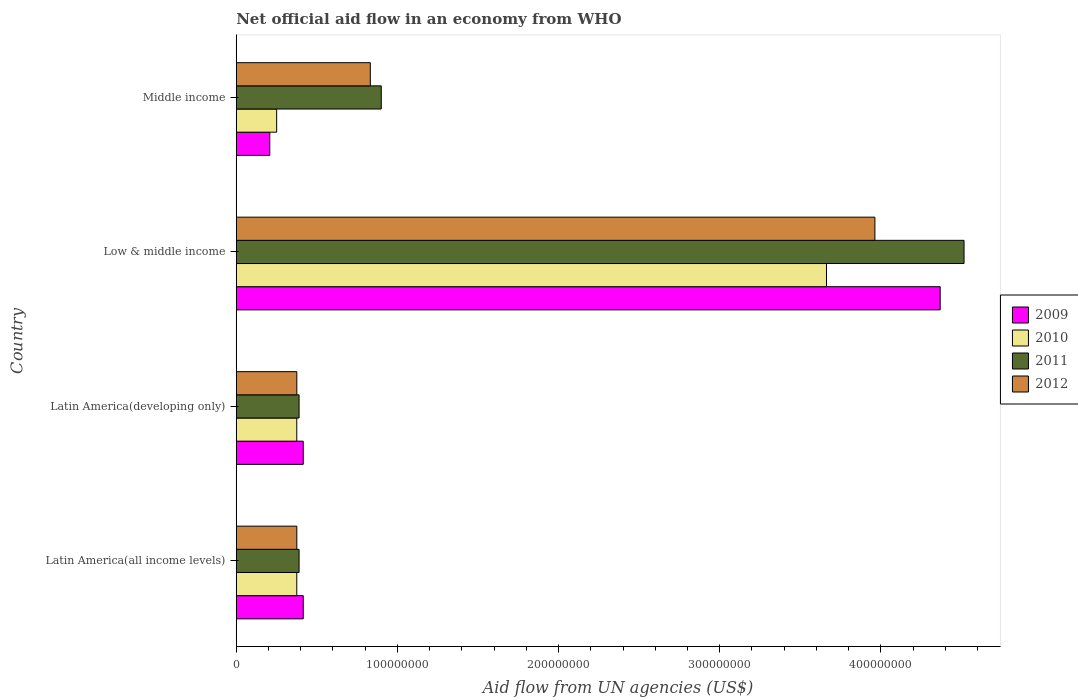Are the number of bars per tick equal to the number of legend labels?
Make the answer very short. Yes. Are the number of bars on each tick of the Y-axis equal?
Provide a short and direct response. Yes. How many bars are there on the 3rd tick from the bottom?
Offer a very short reply. 4. What is the label of the 1st group of bars from the top?
Ensure brevity in your answer.  Middle income. In how many cases, is the number of bars for a given country not equal to the number of legend labels?
Provide a succinct answer. 0. What is the net official aid flow in 2012 in Low & middle income?
Your answer should be very brief. 3.96e+08. Across all countries, what is the maximum net official aid flow in 2010?
Your answer should be very brief. 3.66e+08. Across all countries, what is the minimum net official aid flow in 2011?
Offer a very short reply. 3.90e+07. In which country was the net official aid flow in 2010 minimum?
Keep it short and to the point. Middle income. What is the total net official aid flow in 2011 in the graph?
Make the answer very short. 6.20e+08. What is the difference between the net official aid flow in 2009 in Latin America(all income levels) and that in Low & middle income?
Provide a short and direct response. -3.95e+08. What is the difference between the net official aid flow in 2012 in Latin America(all income levels) and the net official aid flow in 2011 in Latin America(developing only)?
Your answer should be compact. -1.40e+06. What is the average net official aid flow in 2009 per country?
Your answer should be compact. 1.35e+08. What is the difference between the net official aid flow in 2012 and net official aid flow in 2011 in Low & middle income?
Provide a short and direct response. -5.53e+07. What is the ratio of the net official aid flow in 2012 in Latin America(all income levels) to that in Low & middle income?
Offer a terse response. 0.09. Is the net official aid flow in 2012 in Latin America(developing only) less than that in Low & middle income?
Your response must be concise. Yes. Is the difference between the net official aid flow in 2012 in Low & middle income and Middle income greater than the difference between the net official aid flow in 2011 in Low & middle income and Middle income?
Provide a succinct answer. No. What is the difference between the highest and the second highest net official aid flow in 2011?
Make the answer very short. 3.62e+08. What is the difference between the highest and the lowest net official aid flow in 2011?
Your answer should be very brief. 4.13e+08. Is the sum of the net official aid flow in 2011 in Latin America(developing only) and Middle income greater than the maximum net official aid flow in 2009 across all countries?
Give a very brief answer. No. What does the 4th bar from the top in Low & middle income represents?
Give a very brief answer. 2009. What does the 4th bar from the bottom in Latin America(all income levels) represents?
Offer a terse response. 2012. Is it the case that in every country, the sum of the net official aid flow in 2011 and net official aid flow in 2010 is greater than the net official aid flow in 2012?
Offer a very short reply. Yes. How many bars are there?
Offer a terse response. 16. How many countries are there in the graph?
Your answer should be very brief. 4. Are the values on the major ticks of X-axis written in scientific E-notation?
Make the answer very short. No. Does the graph contain any zero values?
Keep it short and to the point. No. Does the graph contain grids?
Provide a succinct answer. No. How many legend labels are there?
Your answer should be very brief. 4. What is the title of the graph?
Make the answer very short. Net official aid flow in an economy from WHO. What is the label or title of the X-axis?
Provide a succinct answer. Aid flow from UN agencies (US$). What is the Aid flow from UN agencies (US$) of 2009 in Latin America(all income levels)?
Offer a terse response. 4.16e+07. What is the Aid flow from UN agencies (US$) of 2010 in Latin America(all income levels)?
Give a very brief answer. 3.76e+07. What is the Aid flow from UN agencies (US$) in 2011 in Latin America(all income levels)?
Your answer should be compact. 3.90e+07. What is the Aid flow from UN agencies (US$) of 2012 in Latin America(all income levels)?
Offer a terse response. 3.76e+07. What is the Aid flow from UN agencies (US$) of 2009 in Latin America(developing only)?
Keep it short and to the point. 4.16e+07. What is the Aid flow from UN agencies (US$) of 2010 in Latin America(developing only)?
Keep it short and to the point. 3.76e+07. What is the Aid flow from UN agencies (US$) in 2011 in Latin America(developing only)?
Your response must be concise. 3.90e+07. What is the Aid flow from UN agencies (US$) of 2012 in Latin America(developing only)?
Keep it short and to the point. 3.76e+07. What is the Aid flow from UN agencies (US$) in 2009 in Low & middle income?
Offer a very short reply. 4.37e+08. What is the Aid flow from UN agencies (US$) in 2010 in Low & middle income?
Give a very brief answer. 3.66e+08. What is the Aid flow from UN agencies (US$) in 2011 in Low & middle income?
Your answer should be compact. 4.52e+08. What is the Aid flow from UN agencies (US$) in 2012 in Low & middle income?
Your answer should be compact. 3.96e+08. What is the Aid flow from UN agencies (US$) of 2009 in Middle income?
Give a very brief answer. 2.08e+07. What is the Aid flow from UN agencies (US$) in 2010 in Middle income?
Provide a short and direct response. 2.51e+07. What is the Aid flow from UN agencies (US$) of 2011 in Middle income?
Make the answer very short. 9.00e+07. What is the Aid flow from UN agencies (US$) of 2012 in Middle income?
Ensure brevity in your answer.  8.32e+07. Across all countries, what is the maximum Aid flow from UN agencies (US$) of 2009?
Give a very brief answer. 4.37e+08. Across all countries, what is the maximum Aid flow from UN agencies (US$) of 2010?
Keep it short and to the point. 3.66e+08. Across all countries, what is the maximum Aid flow from UN agencies (US$) in 2011?
Make the answer very short. 4.52e+08. Across all countries, what is the maximum Aid flow from UN agencies (US$) of 2012?
Your response must be concise. 3.96e+08. Across all countries, what is the minimum Aid flow from UN agencies (US$) of 2009?
Make the answer very short. 2.08e+07. Across all countries, what is the minimum Aid flow from UN agencies (US$) of 2010?
Offer a very short reply. 2.51e+07. Across all countries, what is the minimum Aid flow from UN agencies (US$) of 2011?
Offer a terse response. 3.90e+07. Across all countries, what is the minimum Aid flow from UN agencies (US$) in 2012?
Your response must be concise. 3.76e+07. What is the total Aid flow from UN agencies (US$) of 2009 in the graph?
Provide a short and direct response. 5.41e+08. What is the total Aid flow from UN agencies (US$) of 2010 in the graph?
Your response must be concise. 4.66e+08. What is the total Aid flow from UN agencies (US$) in 2011 in the graph?
Your answer should be compact. 6.20e+08. What is the total Aid flow from UN agencies (US$) in 2012 in the graph?
Keep it short and to the point. 5.55e+08. What is the difference between the Aid flow from UN agencies (US$) in 2009 in Latin America(all income levels) and that in Latin America(developing only)?
Keep it short and to the point. 0. What is the difference between the Aid flow from UN agencies (US$) of 2010 in Latin America(all income levels) and that in Latin America(developing only)?
Ensure brevity in your answer.  0. What is the difference between the Aid flow from UN agencies (US$) of 2011 in Latin America(all income levels) and that in Latin America(developing only)?
Your response must be concise. 0. What is the difference between the Aid flow from UN agencies (US$) in 2009 in Latin America(all income levels) and that in Low & middle income?
Your answer should be very brief. -3.95e+08. What is the difference between the Aid flow from UN agencies (US$) of 2010 in Latin America(all income levels) and that in Low & middle income?
Give a very brief answer. -3.29e+08. What is the difference between the Aid flow from UN agencies (US$) in 2011 in Latin America(all income levels) and that in Low & middle income?
Keep it short and to the point. -4.13e+08. What is the difference between the Aid flow from UN agencies (US$) of 2012 in Latin America(all income levels) and that in Low & middle income?
Ensure brevity in your answer.  -3.59e+08. What is the difference between the Aid flow from UN agencies (US$) in 2009 in Latin America(all income levels) and that in Middle income?
Offer a terse response. 2.08e+07. What is the difference between the Aid flow from UN agencies (US$) in 2010 in Latin America(all income levels) and that in Middle income?
Provide a succinct answer. 1.25e+07. What is the difference between the Aid flow from UN agencies (US$) in 2011 in Latin America(all income levels) and that in Middle income?
Ensure brevity in your answer.  -5.10e+07. What is the difference between the Aid flow from UN agencies (US$) of 2012 in Latin America(all income levels) and that in Middle income?
Your answer should be compact. -4.56e+07. What is the difference between the Aid flow from UN agencies (US$) of 2009 in Latin America(developing only) and that in Low & middle income?
Your answer should be very brief. -3.95e+08. What is the difference between the Aid flow from UN agencies (US$) of 2010 in Latin America(developing only) and that in Low & middle income?
Offer a terse response. -3.29e+08. What is the difference between the Aid flow from UN agencies (US$) of 2011 in Latin America(developing only) and that in Low & middle income?
Provide a succinct answer. -4.13e+08. What is the difference between the Aid flow from UN agencies (US$) of 2012 in Latin America(developing only) and that in Low & middle income?
Offer a very short reply. -3.59e+08. What is the difference between the Aid flow from UN agencies (US$) of 2009 in Latin America(developing only) and that in Middle income?
Keep it short and to the point. 2.08e+07. What is the difference between the Aid flow from UN agencies (US$) in 2010 in Latin America(developing only) and that in Middle income?
Provide a succinct answer. 1.25e+07. What is the difference between the Aid flow from UN agencies (US$) of 2011 in Latin America(developing only) and that in Middle income?
Ensure brevity in your answer.  -5.10e+07. What is the difference between the Aid flow from UN agencies (US$) in 2012 in Latin America(developing only) and that in Middle income?
Provide a short and direct response. -4.56e+07. What is the difference between the Aid flow from UN agencies (US$) of 2009 in Low & middle income and that in Middle income?
Give a very brief answer. 4.16e+08. What is the difference between the Aid flow from UN agencies (US$) of 2010 in Low & middle income and that in Middle income?
Ensure brevity in your answer.  3.41e+08. What is the difference between the Aid flow from UN agencies (US$) in 2011 in Low & middle income and that in Middle income?
Offer a very short reply. 3.62e+08. What is the difference between the Aid flow from UN agencies (US$) of 2012 in Low & middle income and that in Middle income?
Your answer should be very brief. 3.13e+08. What is the difference between the Aid flow from UN agencies (US$) in 2009 in Latin America(all income levels) and the Aid flow from UN agencies (US$) in 2010 in Latin America(developing only)?
Your answer should be very brief. 4.01e+06. What is the difference between the Aid flow from UN agencies (US$) in 2009 in Latin America(all income levels) and the Aid flow from UN agencies (US$) in 2011 in Latin America(developing only)?
Offer a terse response. 2.59e+06. What is the difference between the Aid flow from UN agencies (US$) of 2009 in Latin America(all income levels) and the Aid flow from UN agencies (US$) of 2012 in Latin America(developing only)?
Give a very brief answer. 3.99e+06. What is the difference between the Aid flow from UN agencies (US$) in 2010 in Latin America(all income levels) and the Aid flow from UN agencies (US$) in 2011 in Latin America(developing only)?
Provide a succinct answer. -1.42e+06. What is the difference between the Aid flow from UN agencies (US$) in 2011 in Latin America(all income levels) and the Aid flow from UN agencies (US$) in 2012 in Latin America(developing only)?
Keep it short and to the point. 1.40e+06. What is the difference between the Aid flow from UN agencies (US$) of 2009 in Latin America(all income levels) and the Aid flow from UN agencies (US$) of 2010 in Low & middle income?
Provide a succinct answer. -3.25e+08. What is the difference between the Aid flow from UN agencies (US$) in 2009 in Latin America(all income levels) and the Aid flow from UN agencies (US$) in 2011 in Low & middle income?
Offer a terse response. -4.10e+08. What is the difference between the Aid flow from UN agencies (US$) in 2009 in Latin America(all income levels) and the Aid flow from UN agencies (US$) in 2012 in Low & middle income?
Offer a very short reply. -3.55e+08. What is the difference between the Aid flow from UN agencies (US$) in 2010 in Latin America(all income levels) and the Aid flow from UN agencies (US$) in 2011 in Low & middle income?
Your response must be concise. -4.14e+08. What is the difference between the Aid flow from UN agencies (US$) in 2010 in Latin America(all income levels) and the Aid flow from UN agencies (US$) in 2012 in Low & middle income?
Give a very brief answer. -3.59e+08. What is the difference between the Aid flow from UN agencies (US$) of 2011 in Latin America(all income levels) and the Aid flow from UN agencies (US$) of 2012 in Low & middle income?
Ensure brevity in your answer.  -3.57e+08. What is the difference between the Aid flow from UN agencies (US$) in 2009 in Latin America(all income levels) and the Aid flow from UN agencies (US$) in 2010 in Middle income?
Keep it short and to the point. 1.65e+07. What is the difference between the Aid flow from UN agencies (US$) in 2009 in Latin America(all income levels) and the Aid flow from UN agencies (US$) in 2011 in Middle income?
Ensure brevity in your answer.  -4.84e+07. What is the difference between the Aid flow from UN agencies (US$) of 2009 in Latin America(all income levels) and the Aid flow from UN agencies (US$) of 2012 in Middle income?
Provide a short and direct response. -4.16e+07. What is the difference between the Aid flow from UN agencies (US$) of 2010 in Latin America(all income levels) and the Aid flow from UN agencies (US$) of 2011 in Middle income?
Give a very brief answer. -5.24e+07. What is the difference between the Aid flow from UN agencies (US$) in 2010 in Latin America(all income levels) and the Aid flow from UN agencies (US$) in 2012 in Middle income?
Offer a very short reply. -4.56e+07. What is the difference between the Aid flow from UN agencies (US$) in 2011 in Latin America(all income levels) and the Aid flow from UN agencies (US$) in 2012 in Middle income?
Your answer should be very brief. -4.42e+07. What is the difference between the Aid flow from UN agencies (US$) of 2009 in Latin America(developing only) and the Aid flow from UN agencies (US$) of 2010 in Low & middle income?
Your answer should be very brief. -3.25e+08. What is the difference between the Aid flow from UN agencies (US$) of 2009 in Latin America(developing only) and the Aid flow from UN agencies (US$) of 2011 in Low & middle income?
Your answer should be very brief. -4.10e+08. What is the difference between the Aid flow from UN agencies (US$) of 2009 in Latin America(developing only) and the Aid flow from UN agencies (US$) of 2012 in Low & middle income?
Provide a succinct answer. -3.55e+08. What is the difference between the Aid flow from UN agencies (US$) of 2010 in Latin America(developing only) and the Aid flow from UN agencies (US$) of 2011 in Low & middle income?
Make the answer very short. -4.14e+08. What is the difference between the Aid flow from UN agencies (US$) in 2010 in Latin America(developing only) and the Aid flow from UN agencies (US$) in 2012 in Low & middle income?
Make the answer very short. -3.59e+08. What is the difference between the Aid flow from UN agencies (US$) of 2011 in Latin America(developing only) and the Aid flow from UN agencies (US$) of 2012 in Low & middle income?
Offer a very short reply. -3.57e+08. What is the difference between the Aid flow from UN agencies (US$) of 2009 in Latin America(developing only) and the Aid flow from UN agencies (US$) of 2010 in Middle income?
Your answer should be very brief. 1.65e+07. What is the difference between the Aid flow from UN agencies (US$) of 2009 in Latin America(developing only) and the Aid flow from UN agencies (US$) of 2011 in Middle income?
Provide a short and direct response. -4.84e+07. What is the difference between the Aid flow from UN agencies (US$) of 2009 in Latin America(developing only) and the Aid flow from UN agencies (US$) of 2012 in Middle income?
Provide a short and direct response. -4.16e+07. What is the difference between the Aid flow from UN agencies (US$) of 2010 in Latin America(developing only) and the Aid flow from UN agencies (US$) of 2011 in Middle income?
Your answer should be very brief. -5.24e+07. What is the difference between the Aid flow from UN agencies (US$) in 2010 in Latin America(developing only) and the Aid flow from UN agencies (US$) in 2012 in Middle income?
Give a very brief answer. -4.56e+07. What is the difference between the Aid flow from UN agencies (US$) in 2011 in Latin America(developing only) and the Aid flow from UN agencies (US$) in 2012 in Middle income?
Your answer should be very brief. -4.42e+07. What is the difference between the Aid flow from UN agencies (US$) of 2009 in Low & middle income and the Aid flow from UN agencies (US$) of 2010 in Middle income?
Provide a short and direct response. 4.12e+08. What is the difference between the Aid flow from UN agencies (US$) in 2009 in Low & middle income and the Aid flow from UN agencies (US$) in 2011 in Middle income?
Ensure brevity in your answer.  3.47e+08. What is the difference between the Aid flow from UN agencies (US$) in 2009 in Low & middle income and the Aid flow from UN agencies (US$) in 2012 in Middle income?
Your answer should be very brief. 3.54e+08. What is the difference between the Aid flow from UN agencies (US$) of 2010 in Low & middle income and the Aid flow from UN agencies (US$) of 2011 in Middle income?
Keep it short and to the point. 2.76e+08. What is the difference between the Aid flow from UN agencies (US$) of 2010 in Low & middle income and the Aid flow from UN agencies (US$) of 2012 in Middle income?
Provide a short and direct response. 2.83e+08. What is the difference between the Aid flow from UN agencies (US$) in 2011 in Low & middle income and the Aid flow from UN agencies (US$) in 2012 in Middle income?
Ensure brevity in your answer.  3.68e+08. What is the average Aid flow from UN agencies (US$) of 2009 per country?
Ensure brevity in your answer.  1.35e+08. What is the average Aid flow from UN agencies (US$) in 2010 per country?
Your answer should be very brief. 1.17e+08. What is the average Aid flow from UN agencies (US$) in 2011 per country?
Keep it short and to the point. 1.55e+08. What is the average Aid flow from UN agencies (US$) in 2012 per country?
Your answer should be compact. 1.39e+08. What is the difference between the Aid flow from UN agencies (US$) in 2009 and Aid flow from UN agencies (US$) in 2010 in Latin America(all income levels)?
Your response must be concise. 4.01e+06. What is the difference between the Aid flow from UN agencies (US$) of 2009 and Aid flow from UN agencies (US$) of 2011 in Latin America(all income levels)?
Keep it short and to the point. 2.59e+06. What is the difference between the Aid flow from UN agencies (US$) in 2009 and Aid flow from UN agencies (US$) in 2012 in Latin America(all income levels)?
Your answer should be very brief. 3.99e+06. What is the difference between the Aid flow from UN agencies (US$) of 2010 and Aid flow from UN agencies (US$) of 2011 in Latin America(all income levels)?
Offer a terse response. -1.42e+06. What is the difference between the Aid flow from UN agencies (US$) of 2010 and Aid flow from UN agencies (US$) of 2012 in Latin America(all income levels)?
Ensure brevity in your answer.  -2.00e+04. What is the difference between the Aid flow from UN agencies (US$) in 2011 and Aid flow from UN agencies (US$) in 2012 in Latin America(all income levels)?
Offer a very short reply. 1.40e+06. What is the difference between the Aid flow from UN agencies (US$) of 2009 and Aid flow from UN agencies (US$) of 2010 in Latin America(developing only)?
Ensure brevity in your answer.  4.01e+06. What is the difference between the Aid flow from UN agencies (US$) in 2009 and Aid flow from UN agencies (US$) in 2011 in Latin America(developing only)?
Provide a short and direct response. 2.59e+06. What is the difference between the Aid flow from UN agencies (US$) in 2009 and Aid flow from UN agencies (US$) in 2012 in Latin America(developing only)?
Provide a succinct answer. 3.99e+06. What is the difference between the Aid flow from UN agencies (US$) in 2010 and Aid flow from UN agencies (US$) in 2011 in Latin America(developing only)?
Ensure brevity in your answer.  -1.42e+06. What is the difference between the Aid flow from UN agencies (US$) of 2011 and Aid flow from UN agencies (US$) of 2012 in Latin America(developing only)?
Your answer should be very brief. 1.40e+06. What is the difference between the Aid flow from UN agencies (US$) of 2009 and Aid flow from UN agencies (US$) of 2010 in Low & middle income?
Your answer should be compact. 7.06e+07. What is the difference between the Aid flow from UN agencies (US$) in 2009 and Aid flow from UN agencies (US$) in 2011 in Low & middle income?
Provide a succinct answer. -1.48e+07. What is the difference between the Aid flow from UN agencies (US$) of 2009 and Aid flow from UN agencies (US$) of 2012 in Low & middle income?
Your response must be concise. 4.05e+07. What is the difference between the Aid flow from UN agencies (US$) of 2010 and Aid flow from UN agencies (US$) of 2011 in Low & middle income?
Provide a short and direct response. -8.54e+07. What is the difference between the Aid flow from UN agencies (US$) of 2010 and Aid flow from UN agencies (US$) of 2012 in Low & middle income?
Offer a terse response. -3.00e+07. What is the difference between the Aid flow from UN agencies (US$) in 2011 and Aid flow from UN agencies (US$) in 2012 in Low & middle income?
Your response must be concise. 5.53e+07. What is the difference between the Aid flow from UN agencies (US$) of 2009 and Aid flow from UN agencies (US$) of 2010 in Middle income?
Your answer should be compact. -4.27e+06. What is the difference between the Aid flow from UN agencies (US$) of 2009 and Aid flow from UN agencies (US$) of 2011 in Middle income?
Provide a succinct answer. -6.92e+07. What is the difference between the Aid flow from UN agencies (US$) in 2009 and Aid flow from UN agencies (US$) in 2012 in Middle income?
Provide a succinct answer. -6.24e+07. What is the difference between the Aid flow from UN agencies (US$) in 2010 and Aid flow from UN agencies (US$) in 2011 in Middle income?
Your answer should be very brief. -6.49e+07. What is the difference between the Aid flow from UN agencies (US$) of 2010 and Aid flow from UN agencies (US$) of 2012 in Middle income?
Ensure brevity in your answer.  -5.81e+07. What is the difference between the Aid flow from UN agencies (US$) in 2011 and Aid flow from UN agencies (US$) in 2012 in Middle income?
Provide a succinct answer. 6.80e+06. What is the ratio of the Aid flow from UN agencies (US$) in 2010 in Latin America(all income levels) to that in Latin America(developing only)?
Your answer should be very brief. 1. What is the ratio of the Aid flow from UN agencies (US$) of 2012 in Latin America(all income levels) to that in Latin America(developing only)?
Give a very brief answer. 1. What is the ratio of the Aid flow from UN agencies (US$) of 2009 in Latin America(all income levels) to that in Low & middle income?
Provide a succinct answer. 0.1. What is the ratio of the Aid flow from UN agencies (US$) in 2010 in Latin America(all income levels) to that in Low & middle income?
Your response must be concise. 0.1. What is the ratio of the Aid flow from UN agencies (US$) of 2011 in Latin America(all income levels) to that in Low & middle income?
Offer a terse response. 0.09. What is the ratio of the Aid flow from UN agencies (US$) of 2012 in Latin America(all income levels) to that in Low & middle income?
Provide a short and direct response. 0.09. What is the ratio of the Aid flow from UN agencies (US$) in 2009 in Latin America(all income levels) to that in Middle income?
Your answer should be compact. 2. What is the ratio of the Aid flow from UN agencies (US$) of 2010 in Latin America(all income levels) to that in Middle income?
Offer a terse response. 1.5. What is the ratio of the Aid flow from UN agencies (US$) of 2011 in Latin America(all income levels) to that in Middle income?
Your answer should be very brief. 0.43. What is the ratio of the Aid flow from UN agencies (US$) of 2012 in Latin America(all income levels) to that in Middle income?
Make the answer very short. 0.45. What is the ratio of the Aid flow from UN agencies (US$) of 2009 in Latin America(developing only) to that in Low & middle income?
Your answer should be very brief. 0.1. What is the ratio of the Aid flow from UN agencies (US$) in 2010 in Latin America(developing only) to that in Low & middle income?
Your response must be concise. 0.1. What is the ratio of the Aid flow from UN agencies (US$) in 2011 in Latin America(developing only) to that in Low & middle income?
Offer a very short reply. 0.09. What is the ratio of the Aid flow from UN agencies (US$) in 2012 in Latin America(developing only) to that in Low & middle income?
Your response must be concise. 0.09. What is the ratio of the Aid flow from UN agencies (US$) in 2009 in Latin America(developing only) to that in Middle income?
Offer a terse response. 2. What is the ratio of the Aid flow from UN agencies (US$) in 2010 in Latin America(developing only) to that in Middle income?
Offer a terse response. 1.5. What is the ratio of the Aid flow from UN agencies (US$) in 2011 in Latin America(developing only) to that in Middle income?
Your answer should be very brief. 0.43. What is the ratio of the Aid flow from UN agencies (US$) of 2012 in Latin America(developing only) to that in Middle income?
Keep it short and to the point. 0.45. What is the ratio of the Aid flow from UN agencies (US$) of 2009 in Low & middle income to that in Middle income?
Offer a very short reply. 21. What is the ratio of the Aid flow from UN agencies (US$) in 2010 in Low & middle income to that in Middle income?
Your answer should be compact. 14.61. What is the ratio of the Aid flow from UN agencies (US$) in 2011 in Low & middle income to that in Middle income?
Your answer should be compact. 5.02. What is the ratio of the Aid flow from UN agencies (US$) in 2012 in Low & middle income to that in Middle income?
Your answer should be compact. 4.76. What is the difference between the highest and the second highest Aid flow from UN agencies (US$) in 2009?
Ensure brevity in your answer.  3.95e+08. What is the difference between the highest and the second highest Aid flow from UN agencies (US$) of 2010?
Your response must be concise. 3.29e+08. What is the difference between the highest and the second highest Aid flow from UN agencies (US$) in 2011?
Your answer should be very brief. 3.62e+08. What is the difference between the highest and the second highest Aid flow from UN agencies (US$) of 2012?
Offer a terse response. 3.13e+08. What is the difference between the highest and the lowest Aid flow from UN agencies (US$) in 2009?
Your answer should be very brief. 4.16e+08. What is the difference between the highest and the lowest Aid flow from UN agencies (US$) in 2010?
Offer a terse response. 3.41e+08. What is the difference between the highest and the lowest Aid flow from UN agencies (US$) in 2011?
Offer a very short reply. 4.13e+08. What is the difference between the highest and the lowest Aid flow from UN agencies (US$) of 2012?
Give a very brief answer. 3.59e+08. 